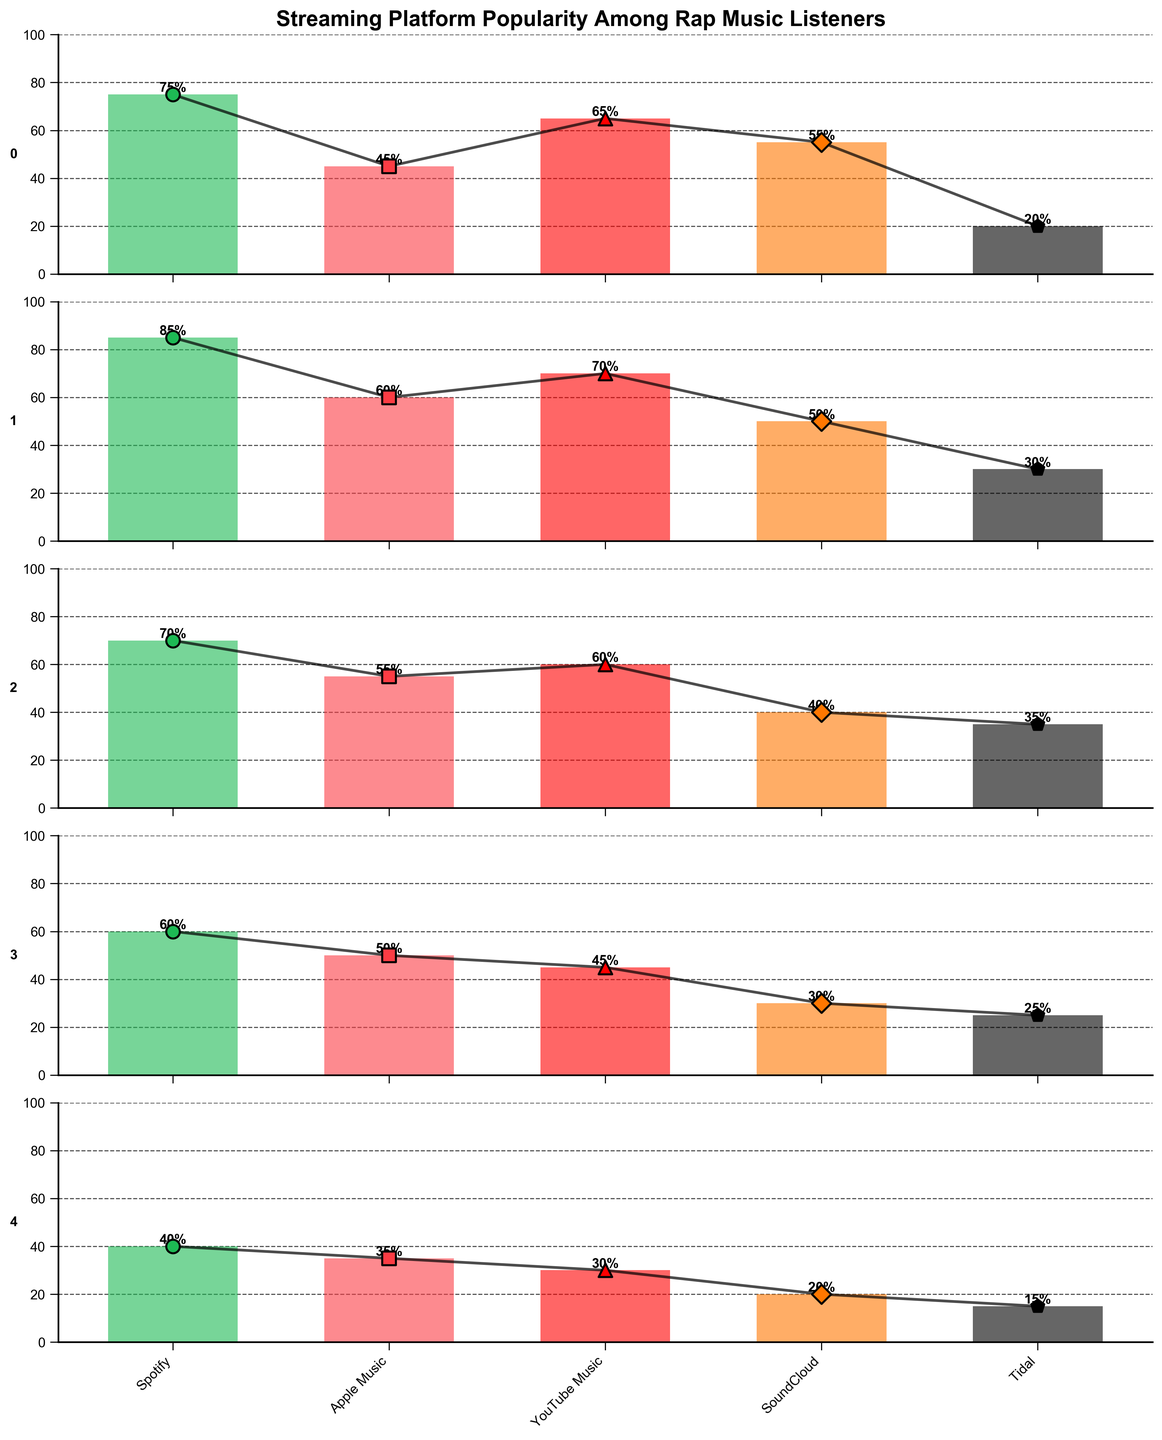What is the title of the figure? The title of the figure is noted at the top of the plot in large, bold text.
Answer: Streaming Platform Popularity Among Rap Music Listeners Which age group shows the highest percentage for Spotify? Look at the subplot for each age group and identify the highest percentage listed for Spotify.
Answer: 18-24 Which streaming platform is least popular among the 13-17 age group? Examine the values for each streaming platform within the 13-17 age group's subplot and determine the lowest percentage.
Answer: Tidal How does the popularity of Apple Music compare between the 35-44 and 45-54 age groups? Compare the percentages of Apple Music for both age groups by examining their respective subplots and noting the values.
Answer: Apple Music is more popular in the 35-44 age group (50%) compared to the 45-54 age group (35%) Which two age groups have the closest percentage values for SoundCloud? Find the values for SoundCloud in each age group's subplot and identify the two groups whose percentages are most similar.
Answer: 13-17 and 18-24 What is the second most popular streaming platform for the 25-34 age group? Identify the streaming platform with the next highest value after the most popular one in the 25-34 age group's subplot.
Answer: Apple Music Calculate the average popularity of YouTube Music across all age groups. Sum the percentages of YouTube Music across all age groups and divide by the number of age groups to find the average.
Answer: (65+70+60+45+30)/5 = 54 What trend do you observe for Spotify popularity as the age increases from 13-17 to 45-54? Look at the values for Spotify across different age groups and describe the pattern observed as the age increases from the youngest to the oldest group.
Answer: Spotify popularity generally decreases as age increases Which age group has the smallest difference between the highest and lowest popularity percentages among streaming platforms? For each age group, find the difference between the highest and lowest percentages, then identify the age group with the smallest gap.
Answer: 35-44 Is there any age group where YouTube Music has the highest popularity percentage compared to other platforms? Check the subplots for each age group to see if YouTube Music has the highest percentage value compared to other streaming platforms in that group.
Answer: No 